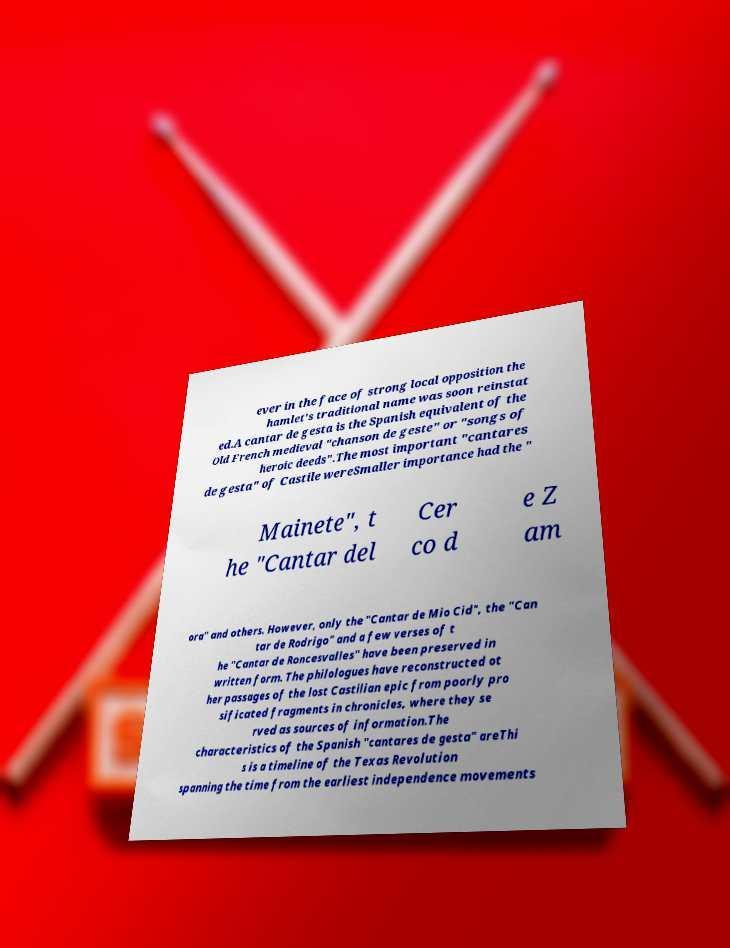Please identify and transcribe the text found in this image. ever in the face of strong local opposition the hamlet's traditional name was soon reinstat ed.A cantar de gesta is the Spanish equivalent of the Old French medieval "chanson de geste" or "songs of heroic deeds".The most important "cantares de gesta" of Castile wereSmaller importance had the " Mainete", t he "Cantar del Cer co d e Z am ora" and others. However, only the "Cantar de Mio Cid", the "Can tar de Rodrigo" and a few verses of t he "Cantar de Roncesvalles" have been preserved in written form. The philologues have reconstructed ot her passages of the lost Castilian epic from poorly pro sificated fragments in chronicles, where they se rved as sources of information.The characteristics of the Spanish "cantares de gesta" areThi s is a timeline of the Texas Revolution spanning the time from the earliest independence movements 